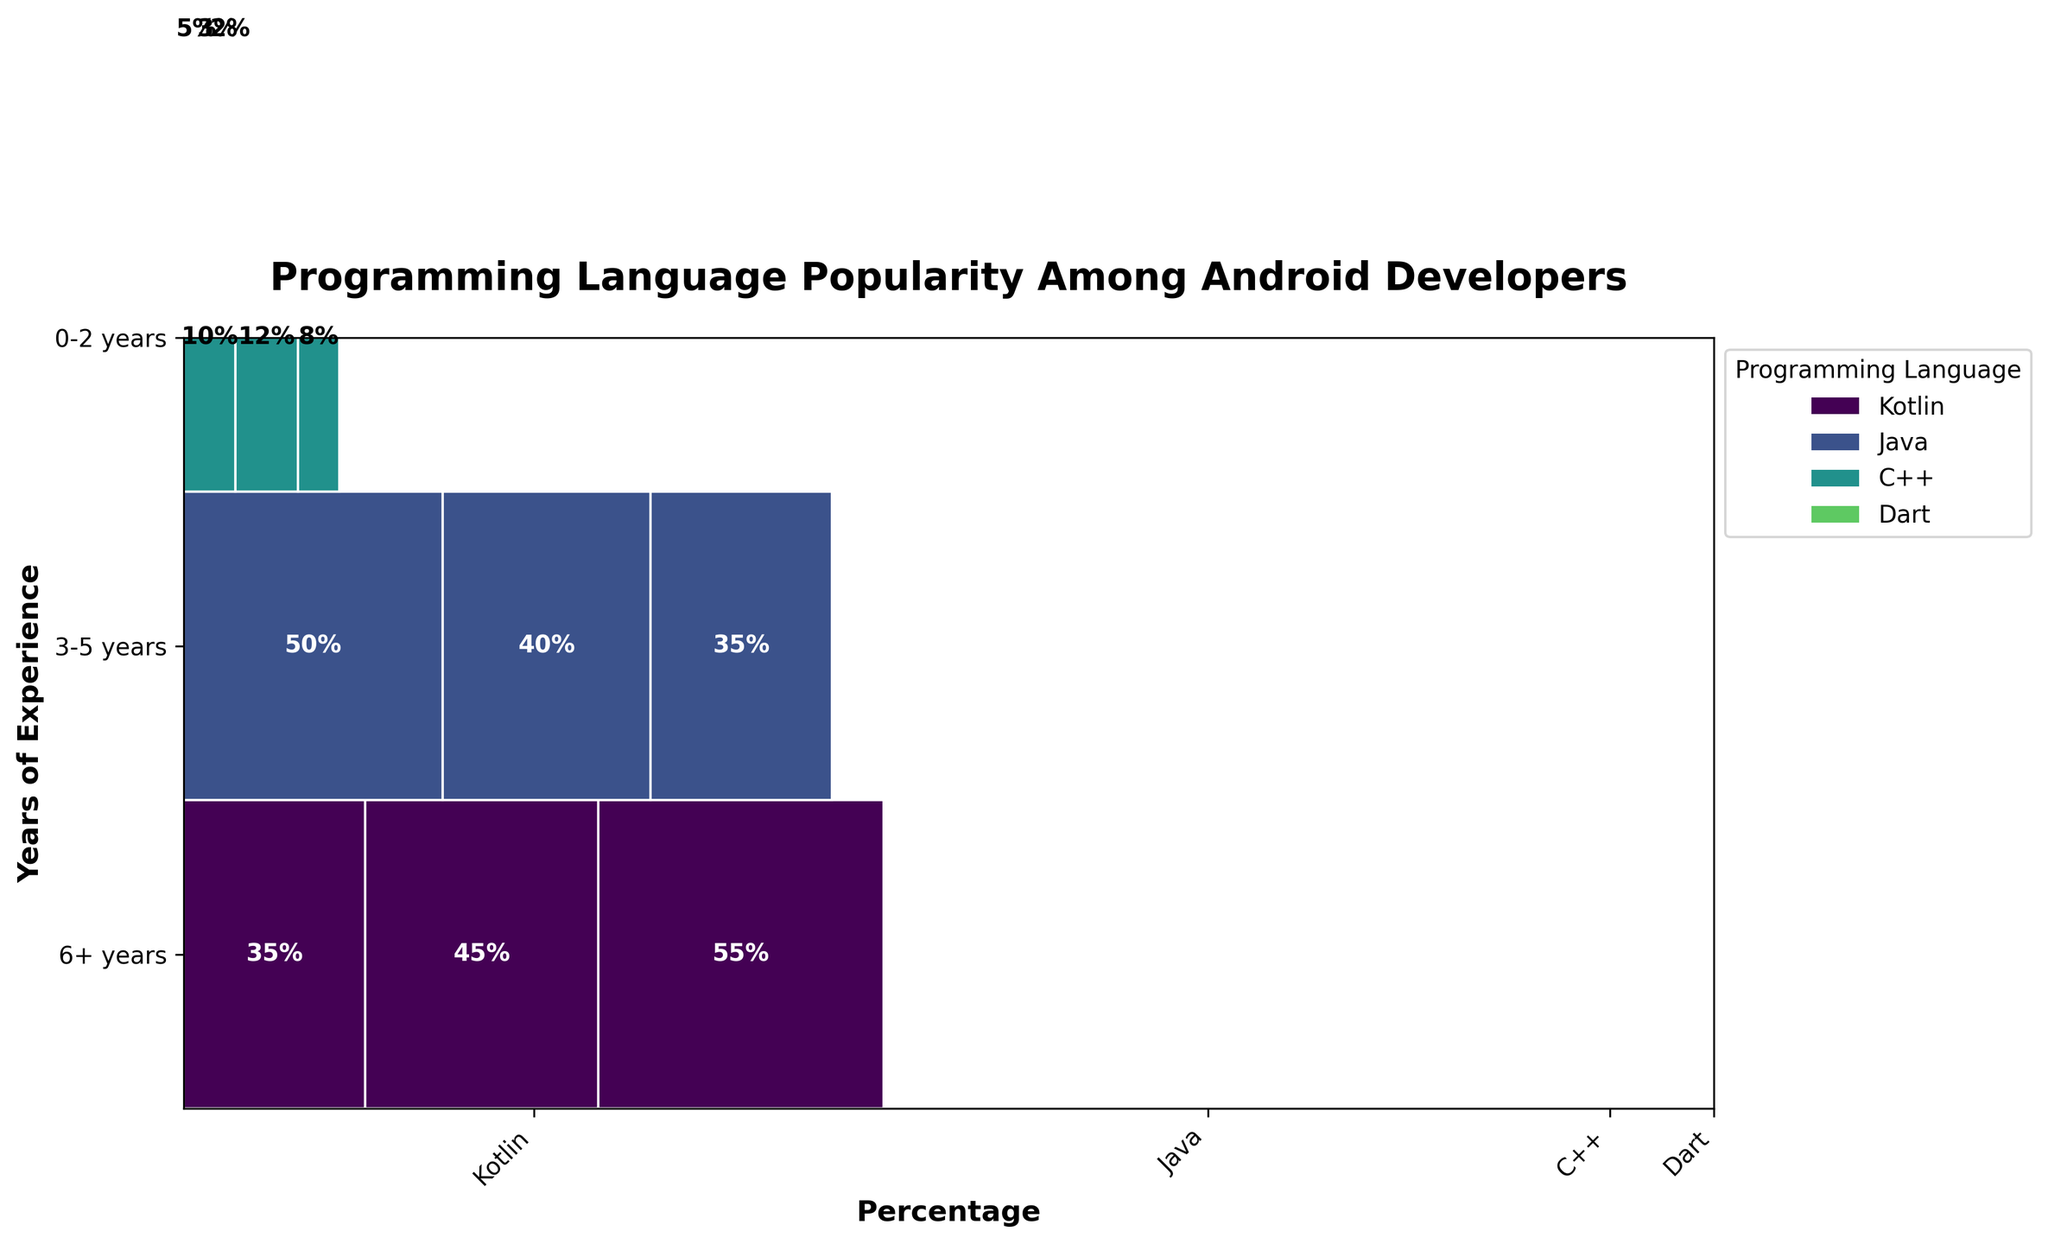What's the title of the plot? The title of the plot is written in a larger font size and boldface at the top center of the plot. It gives a quick overview of the data visualized.
Answer: Programming Language Popularity Among Android Developers What percentage of Kotlin users have 6+ years of experience? Look for the section labeled "Kotlin" and check the part representing 6+ years of experience. The percentage is written inside this section.
Answer: 55% Which experience bracket has the largest proportion of Java users? Find the sections labeled "Java." Compare the percentages in different experience brackets (0-2 years, 3-5 years, 6+ years). The largest proportion will be the highest percentage.
Answer: 0-2 years How does the percentage of Dart users with 0-2 years of experience compare to those with 6+ years? Locate the sections for Dart in the experience brackets 0-2 years and 6+ years. Compare the percentages written inside these sections.
Answer: 5% for 0-2 years and 2% for 6+ years Which programming language is the least popular among Android developers with 6+ years of experience? Analyze the 6+ years experience sections for all programming languages and identify the one with the smallest percentage.
Answer: Dart What is the sum of percentages of Java users across all experience levels? Add the percentages of Java users in all experience categories (0-2 years, 3-5 years, 6+ years) together: 50% + 40% + 35%
Answer: 125% Which programming language shows a trend of increasing popularity with more experience? Identify the programming language whose percentages increase as the years of experience increase. Compare each program's percentages across all experience levels.
Answer: Kotlin How much higher is the percentage of Kotlin users with 3-5 years of experience compared to C++ users in the same bracket? Subtract the percentage of C++ users with 3-5 years of experience from the percentage of Kotlin users with the same level of experience: 45% - 12%
Answer: 33% What percentage range are most programming languages within for the 0-2 years experience bracket? Look at all the percentages for the 0-2 years experience bracket and identify the range in which most of them fall. The commonly observed percentages are: Kotlin (35%), Java (50%), C++ (10%), Dart (5%).
Answer: 5% - 50% What total percentage of Android developers use Kotlin or Java regardless of experience? To find this, add up the percentages of Kotlin and Java users in each experience bracket: (35% + 45% + 55%) + (50% + 40% + 35%)
Answer: 260% Which programming language has the smallest variation in usage percentage across different experience levels? Find the programming language with the smallest difference between its highest and lowest percentages across all experience levels. Compare the percentages of each language: Kotlin (35% - 55%), Java (35% - 50%), C++ (8% - 12%), Dart (2% - 5%).
Answer: C++ 